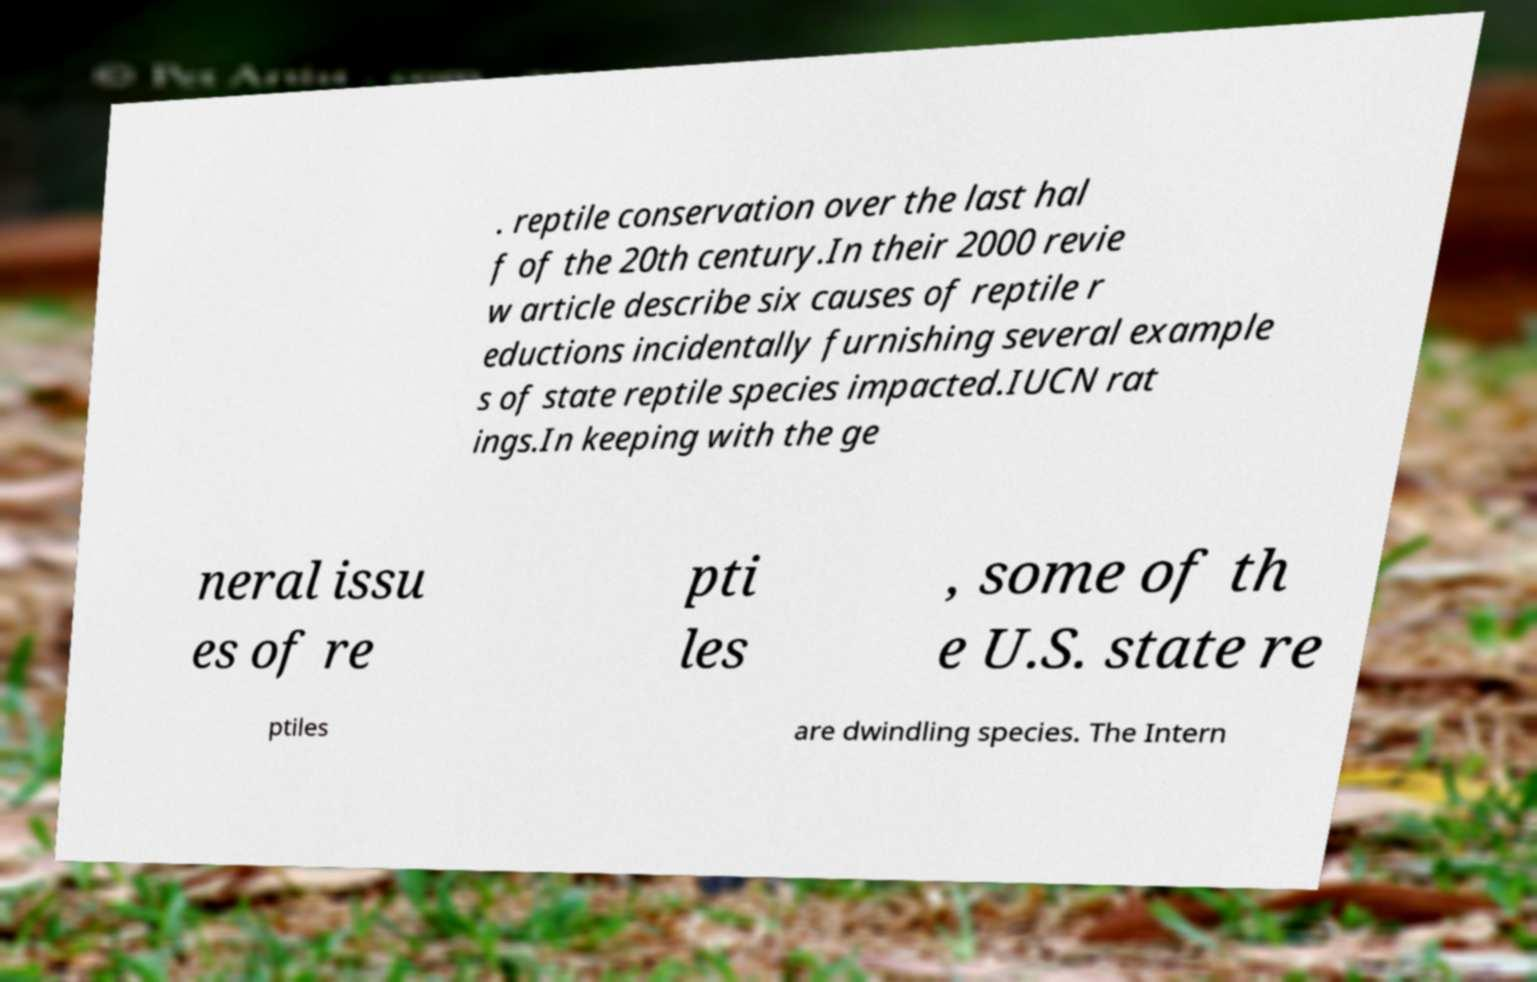There's text embedded in this image that I need extracted. Can you transcribe it verbatim? . reptile conservation over the last hal f of the 20th century.In their 2000 revie w article describe six causes of reptile r eductions incidentally furnishing several example s of state reptile species impacted.IUCN rat ings.In keeping with the ge neral issu es of re pti les , some of th e U.S. state re ptiles are dwindling species. The Intern 